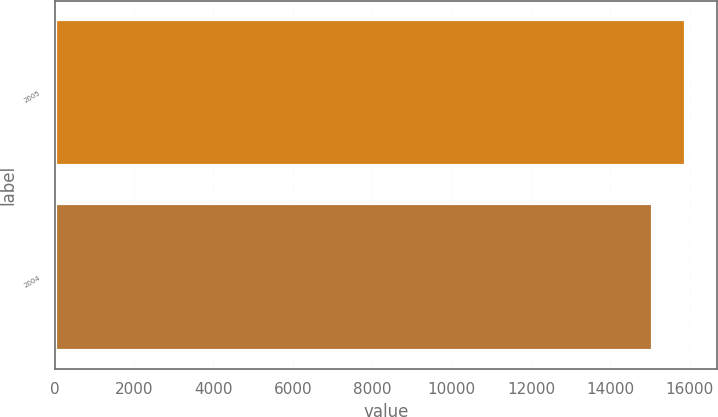Convert chart. <chart><loc_0><loc_0><loc_500><loc_500><bar_chart><fcel>2005<fcel>2004<nl><fcel>15902.6<fcel>15083.2<nl></chart> 